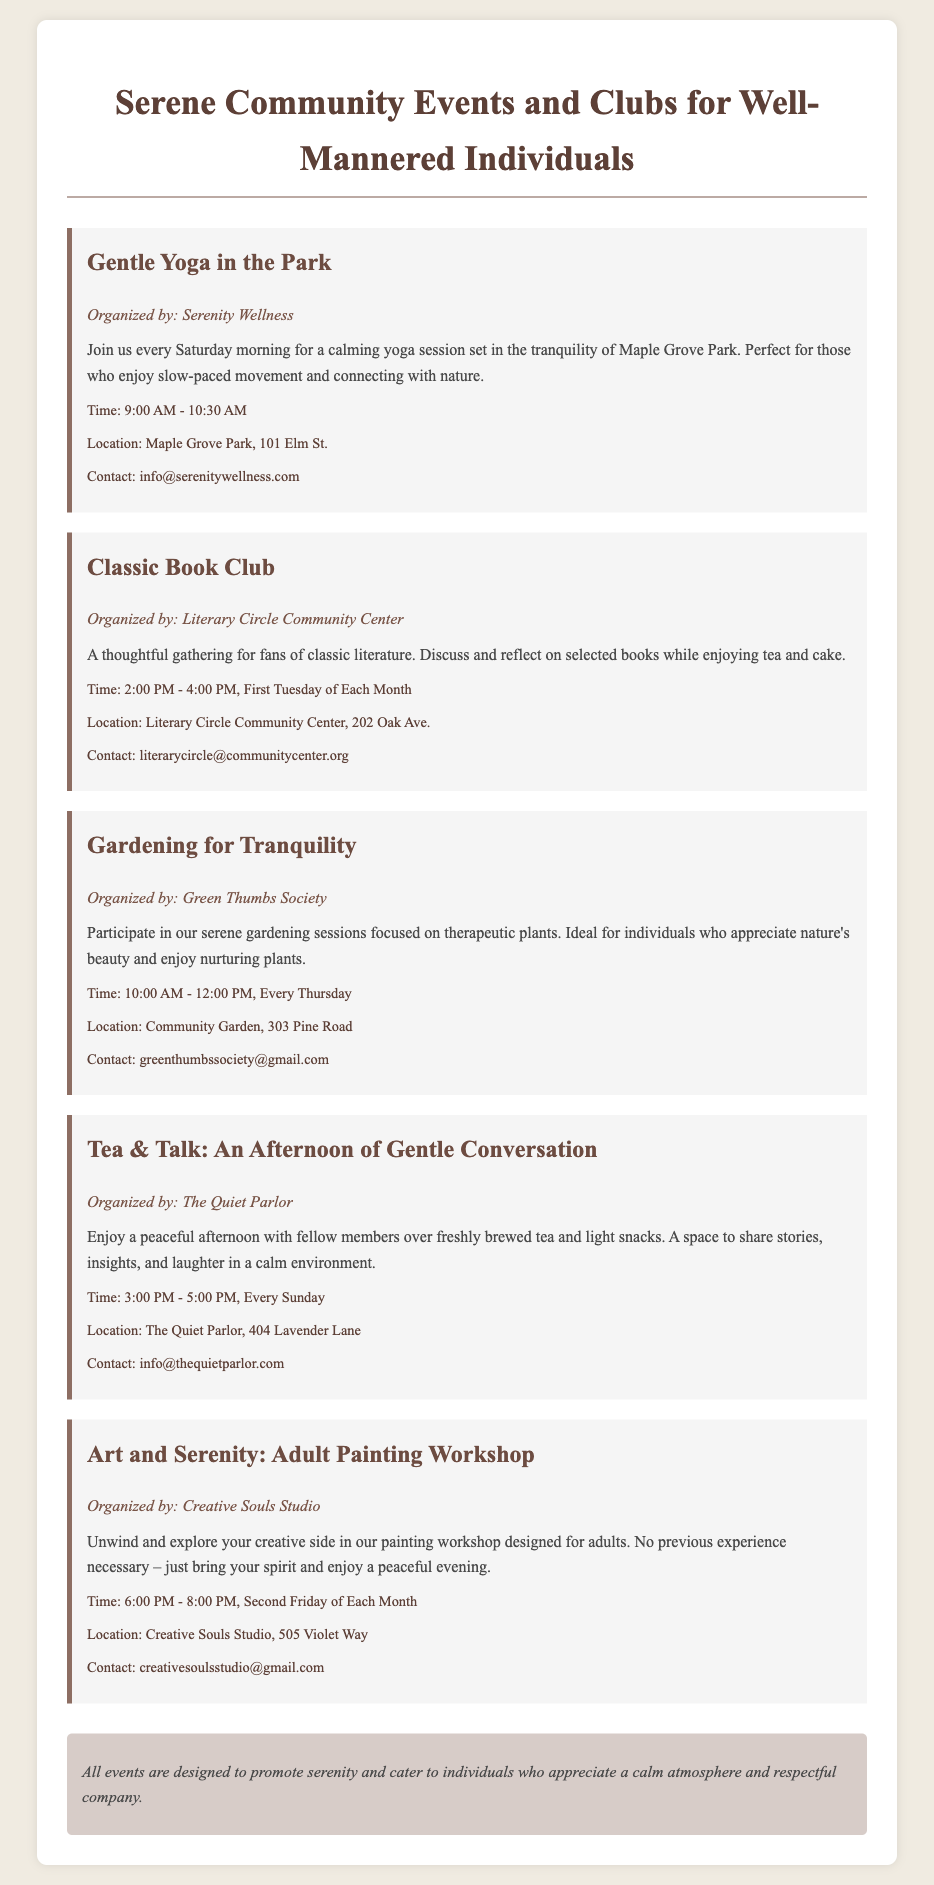What is the title of the catalog? The title at the top of the document states the purpose of the catalog and is indicated clearly.
Answer: Serene Community Events and Clubs for Well-Mannered Individuals What time does the Gentle Yoga event start? The specific time for the Gentle Yoga in the Park is listed in the event details.
Answer: 9:00 AM On which day does the Classic Book Club meet? This information is found in the event description for the Classic Book Club, which specifies its schedule.
Answer: First Tuesday of Each Month Which organization is responsible for the Gardening for Tranquility event? The organizing body for the Gardening for Tranquility event is mentioned directly in the description.
Answer: Green Thumbs Society What type of workshop is offered by Creative Souls Studio? The document describes the nature of the workshop being hosted, indicating its focus.
Answer: Adult Painting Workshop How often does the Tea & Talk event occur? This frequency can be found in the details of the Tea & Talk event within the document.
Answer: Every Sunday What is the location of the Gardening for Tranquility event? The specific address for the Gardening for Tranquility event is given in the description.
Answer: Community Garden, 303 Pine Road What is the main theme of all the events listed in the catalog? The catalog summarizes the primary purpose or theme that ties all events together, visible in the note section.
Answer: Serenity and respect 